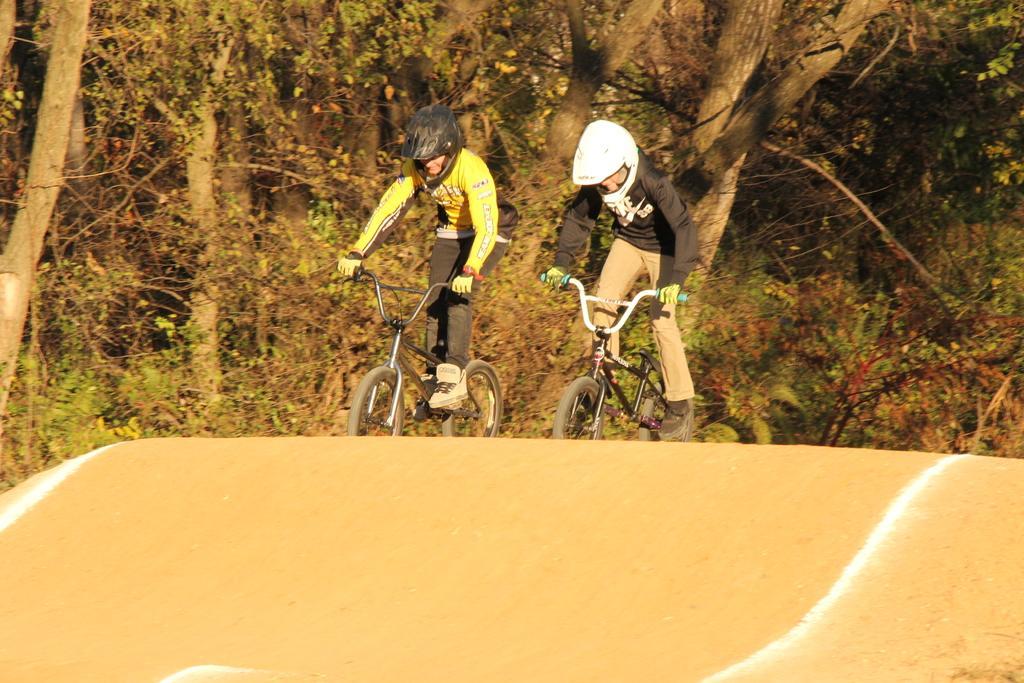Can you describe this image briefly? In this picture there are two persons riding bicycle. At the back there are trees. At the bottom there is a mud road. 